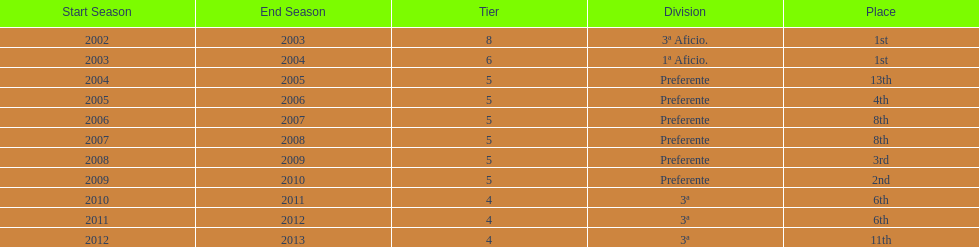What was the number of wins for preferente? 6. 